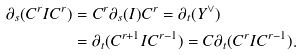Convert formula to latex. <formula><loc_0><loc_0><loc_500><loc_500>\partial _ { s } ( C ^ { r } I C ^ { r } ) & = C ^ { r } \partial _ { s } ( I ) C ^ { r } = \partial _ { t } ( Y ^ { \vee } ) \\ & = \partial _ { t } ( C ^ { r + 1 } I C ^ { r - 1 } ) = C \partial _ { t } ( C ^ { r } I C ^ { r - 1 } ) .</formula> 